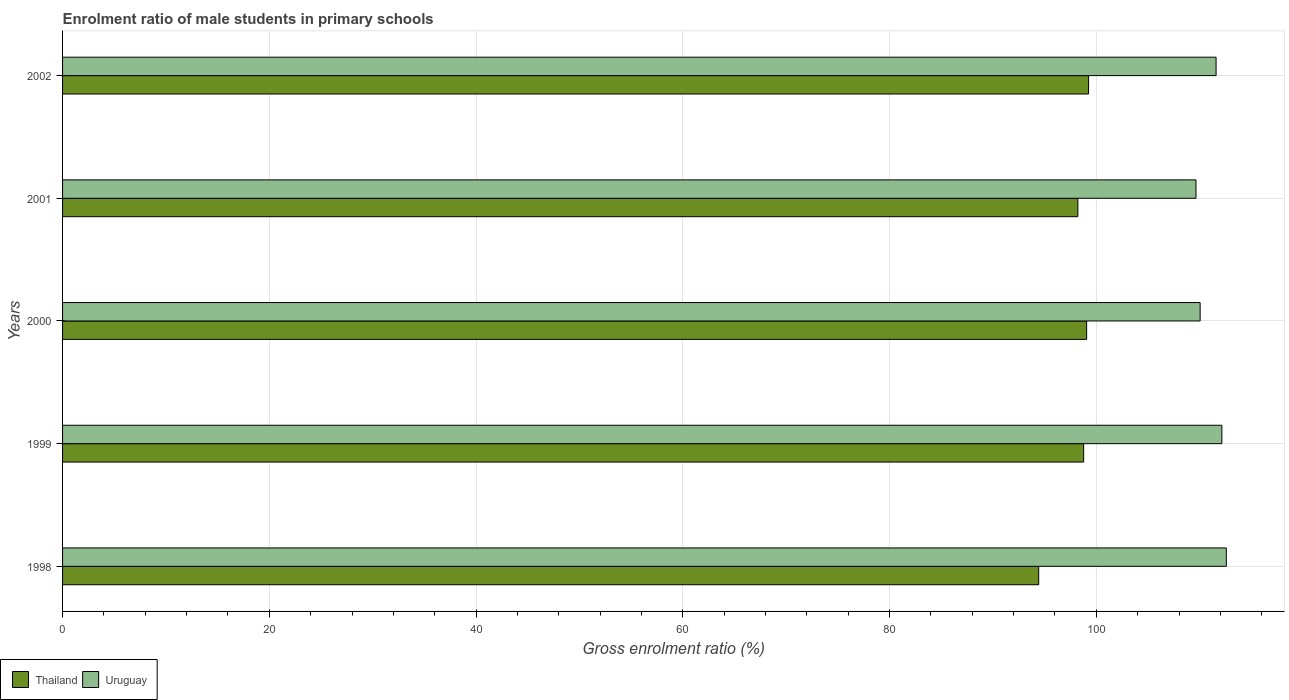How many groups of bars are there?
Your answer should be very brief. 5. Are the number of bars per tick equal to the number of legend labels?
Offer a terse response. Yes. How many bars are there on the 3rd tick from the bottom?
Offer a very short reply. 2. In how many cases, is the number of bars for a given year not equal to the number of legend labels?
Your response must be concise. 0. What is the enrolment ratio of male students in primary schools in Uruguay in 1999?
Offer a very short reply. 112.14. Across all years, what is the maximum enrolment ratio of male students in primary schools in Uruguay?
Offer a terse response. 112.57. Across all years, what is the minimum enrolment ratio of male students in primary schools in Thailand?
Your answer should be compact. 94.43. In which year was the enrolment ratio of male students in primary schools in Thailand maximum?
Keep it short and to the point. 2002. In which year was the enrolment ratio of male students in primary schools in Thailand minimum?
Provide a succinct answer. 1998. What is the total enrolment ratio of male students in primary schools in Thailand in the graph?
Keep it short and to the point. 489.72. What is the difference between the enrolment ratio of male students in primary schools in Uruguay in 1998 and that in 2002?
Ensure brevity in your answer.  0.99. What is the difference between the enrolment ratio of male students in primary schools in Uruguay in 2000 and the enrolment ratio of male students in primary schools in Thailand in 1998?
Make the answer very short. 15.62. What is the average enrolment ratio of male students in primary schools in Thailand per year?
Provide a succinct answer. 97.94. In the year 2002, what is the difference between the enrolment ratio of male students in primary schools in Thailand and enrolment ratio of male students in primary schools in Uruguay?
Your response must be concise. -12.33. What is the ratio of the enrolment ratio of male students in primary schools in Uruguay in 2000 to that in 2001?
Provide a short and direct response. 1. Is the enrolment ratio of male students in primary schools in Uruguay in 1999 less than that in 2002?
Your answer should be compact. No. Is the difference between the enrolment ratio of male students in primary schools in Thailand in 2001 and 2002 greater than the difference between the enrolment ratio of male students in primary schools in Uruguay in 2001 and 2002?
Offer a terse response. Yes. What is the difference between the highest and the second highest enrolment ratio of male students in primary schools in Thailand?
Give a very brief answer. 0.19. What is the difference between the highest and the lowest enrolment ratio of male students in primary schools in Thailand?
Your answer should be very brief. 4.82. What does the 2nd bar from the top in 2000 represents?
Keep it short and to the point. Thailand. What does the 2nd bar from the bottom in 2000 represents?
Your response must be concise. Uruguay. How many bars are there?
Give a very brief answer. 10. Are all the bars in the graph horizontal?
Keep it short and to the point. Yes. How many years are there in the graph?
Give a very brief answer. 5. Does the graph contain any zero values?
Give a very brief answer. No. How many legend labels are there?
Provide a succinct answer. 2. What is the title of the graph?
Provide a short and direct response. Enrolment ratio of male students in primary schools. What is the Gross enrolment ratio (%) of Thailand in 1998?
Provide a succinct answer. 94.43. What is the Gross enrolment ratio (%) in Uruguay in 1998?
Your answer should be compact. 112.57. What is the Gross enrolment ratio (%) in Thailand in 1999?
Give a very brief answer. 98.77. What is the Gross enrolment ratio (%) in Uruguay in 1999?
Your response must be concise. 112.14. What is the Gross enrolment ratio (%) of Thailand in 2000?
Offer a terse response. 99.06. What is the Gross enrolment ratio (%) in Uruguay in 2000?
Offer a terse response. 110.04. What is the Gross enrolment ratio (%) in Thailand in 2001?
Provide a short and direct response. 98.21. What is the Gross enrolment ratio (%) in Uruguay in 2001?
Ensure brevity in your answer.  109.64. What is the Gross enrolment ratio (%) of Thailand in 2002?
Offer a terse response. 99.25. What is the Gross enrolment ratio (%) of Uruguay in 2002?
Keep it short and to the point. 111.58. Across all years, what is the maximum Gross enrolment ratio (%) of Thailand?
Ensure brevity in your answer.  99.25. Across all years, what is the maximum Gross enrolment ratio (%) in Uruguay?
Ensure brevity in your answer.  112.57. Across all years, what is the minimum Gross enrolment ratio (%) in Thailand?
Provide a succinct answer. 94.43. Across all years, what is the minimum Gross enrolment ratio (%) of Uruguay?
Provide a succinct answer. 109.64. What is the total Gross enrolment ratio (%) of Thailand in the graph?
Provide a succinct answer. 489.72. What is the total Gross enrolment ratio (%) in Uruguay in the graph?
Offer a terse response. 555.98. What is the difference between the Gross enrolment ratio (%) in Thailand in 1998 and that in 1999?
Give a very brief answer. -4.35. What is the difference between the Gross enrolment ratio (%) in Uruguay in 1998 and that in 1999?
Ensure brevity in your answer.  0.43. What is the difference between the Gross enrolment ratio (%) of Thailand in 1998 and that in 2000?
Give a very brief answer. -4.64. What is the difference between the Gross enrolment ratio (%) in Uruguay in 1998 and that in 2000?
Your answer should be compact. 2.53. What is the difference between the Gross enrolment ratio (%) of Thailand in 1998 and that in 2001?
Offer a very short reply. -3.79. What is the difference between the Gross enrolment ratio (%) of Uruguay in 1998 and that in 2001?
Your answer should be compact. 2.93. What is the difference between the Gross enrolment ratio (%) of Thailand in 1998 and that in 2002?
Give a very brief answer. -4.82. What is the difference between the Gross enrolment ratio (%) of Uruguay in 1998 and that in 2002?
Ensure brevity in your answer.  0.99. What is the difference between the Gross enrolment ratio (%) of Thailand in 1999 and that in 2000?
Offer a terse response. -0.29. What is the difference between the Gross enrolment ratio (%) of Uruguay in 1999 and that in 2000?
Make the answer very short. 2.1. What is the difference between the Gross enrolment ratio (%) of Thailand in 1999 and that in 2001?
Make the answer very short. 0.56. What is the difference between the Gross enrolment ratio (%) of Uruguay in 1999 and that in 2001?
Make the answer very short. 2.5. What is the difference between the Gross enrolment ratio (%) in Thailand in 1999 and that in 2002?
Provide a short and direct response. -0.48. What is the difference between the Gross enrolment ratio (%) in Uruguay in 1999 and that in 2002?
Offer a very short reply. 0.56. What is the difference between the Gross enrolment ratio (%) of Thailand in 2000 and that in 2001?
Ensure brevity in your answer.  0.85. What is the difference between the Gross enrolment ratio (%) in Uruguay in 2000 and that in 2001?
Your answer should be very brief. 0.4. What is the difference between the Gross enrolment ratio (%) in Thailand in 2000 and that in 2002?
Your response must be concise. -0.19. What is the difference between the Gross enrolment ratio (%) in Uruguay in 2000 and that in 2002?
Offer a terse response. -1.54. What is the difference between the Gross enrolment ratio (%) of Thailand in 2001 and that in 2002?
Keep it short and to the point. -1.03. What is the difference between the Gross enrolment ratio (%) in Uruguay in 2001 and that in 2002?
Your response must be concise. -1.94. What is the difference between the Gross enrolment ratio (%) of Thailand in 1998 and the Gross enrolment ratio (%) of Uruguay in 1999?
Offer a very short reply. -17.72. What is the difference between the Gross enrolment ratio (%) of Thailand in 1998 and the Gross enrolment ratio (%) of Uruguay in 2000?
Give a very brief answer. -15.62. What is the difference between the Gross enrolment ratio (%) of Thailand in 1998 and the Gross enrolment ratio (%) of Uruguay in 2001?
Offer a very short reply. -15.21. What is the difference between the Gross enrolment ratio (%) in Thailand in 1998 and the Gross enrolment ratio (%) in Uruguay in 2002?
Offer a very short reply. -17.16. What is the difference between the Gross enrolment ratio (%) in Thailand in 1999 and the Gross enrolment ratio (%) in Uruguay in 2000?
Your response must be concise. -11.27. What is the difference between the Gross enrolment ratio (%) in Thailand in 1999 and the Gross enrolment ratio (%) in Uruguay in 2001?
Your answer should be very brief. -10.87. What is the difference between the Gross enrolment ratio (%) in Thailand in 1999 and the Gross enrolment ratio (%) in Uruguay in 2002?
Your answer should be very brief. -12.81. What is the difference between the Gross enrolment ratio (%) in Thailand in 2000 and the Gross enrolment ratio (%) in Uruguay in 2001?
Your answer should be very brief. -10.58. What is the difference between the Gross enrolment ratio (%) in Thailand in 2000 and the Gross enrolment ratio (%) in Uruguay in 2002?
Ensure brevity in your answer.  -12.52. What is the difference between the Gross enrolment ratio (%) of Thailand in 2001 and the Gross enrolment ratio (%) of Uruguay in 2002?
Offer a terse response. -13.37. What is the average Gross enrolment ratio (%) in Thailand per year?
Your response must be concise. 97.94. What is the average Gross enrolment ratio (%) of Uruguay per year?
Ensure brevity in your answer.  111.2. In the year 1998, what is the difference between the Gross enrolment ratio (%) of Thailand and Gross enrolment ratio (%) of Uruguay?
Keep it short and to the point. -18.15. In the year 1999, what is the difference between the Gross enrolment ratio (%) of Thailand and Gross enrolment ratio (%) of Uruguay?
Offer a terse response. -13.37. In the year 2000, what is the difference between the Gross enrolment ratio (%) of Thailand and Gross enrolment ratio (%) of Uruguay?
Ensure brevity in your answer.  -10.98. In the year 2001, what is the difference between the Gross enrolment ratio (%) in Thailand and Gross enrolment ratio (%) in Uruguay?
Your answer should be compact. -11.43. In the year 2002, what is the difference between the Gross enrolment ratio (%) in Thailand and Gross enrolment ratio (%) in Uruguay?
Keep it short and to the point. -12.33. What is the ratio of the Gross enrolment ratio (%) in Thailand in 1998 to that in 1999?
Your response must be concise. 0.96. What is the ratio of the Gross enrolment ratio (%) of Uruguay in 1998 to that in 1999?
Make the answer very short. 1. What is the ratio of the Gross enrolment ratio (%) of Thailand in 1998 to that in 2000?
Your answer should be very brief. 0.95. What is the ratio of the Gross enrolment ratio (%) in Thailand in 1998 to that in 2001?
Provide a short and direct response. 0.96. What is the ratio of the Gross enrolment ratio (%) of Uruguay in 1998 to that in 2001?
Provide a succinct answer. 1.03. What is the ratio of the Gross enrolment ratio (%) of Thailand in 1998 to that in 2002?
Offer a very short reply. 0.95. What is the ratio of the Gross enrolment ratio (%) of Uruguay in 1998 to that in 2002?
Ensure brevity in your answer.  1.01. What is the ratio of the Gross enrolment ratio (%) of Uruguay in 1999 to that in 2000?
Make the answer very short. 1.02. What is the ratio of the Gross enrolment ratio (%) of Thailand in 1999 to that in 2001?
Offer a terse response. 1.01. What is the ratio of the Gross enrolment ratio (%) in Uruguay in 1999 to that in 2001?
Offer a very short reply. 1.02. What is the ratio of the Gross enrolment ratio (%) in Thailand in 1999 to that in 2002?
Your response must be concise. 1. What is the ratio of the Gross enrolment ratio (%) in Uruguay in 1999 to that in 2002?
Your answer should be very brief. 1. What is the ratio of the Gross enrolment ratio (%) of Thailand in 2000 to that in 2001?
Provide a succinct answer. 1.01. What is the ratio of the Gross enrolment ratio (%) in Uruguay in 2000 to that in 2001?
Keep it short and to the point. 1. What is the ratio of the Gross enrolment ratio (%) of Uruguay in 2000 to that in 2002?
Your response must be concise. 0.99. What is the ratio of the Gross enrolment ratio (%) in Thailand in 2001 to that in 2002?
Provide a short and direct response. 0.99. What is the ratio of the Gross enrolment ratio (%) of Uruguay in 2001 to that in 2002?
Ensure brevity in your answer.  0.98. What is the difference between the highest and the second highest Gross enrolment ratio (%) of Thailand?
Ensure brevity in your answer.  0.19. What is the difference between the highest and the second highest Gross enrolment ratio (%) of Uruguay?
Offer a very short reply. 0.43. What is the difference between the highest and the lowest Gross enrolment ratio (%) of Thailand?
Offer a very short reply. 4.82. What is the difference between the highest and the lowest Gross enrolment ratio (%) in Uruguay?
Offer a very short reply. 2.93. 